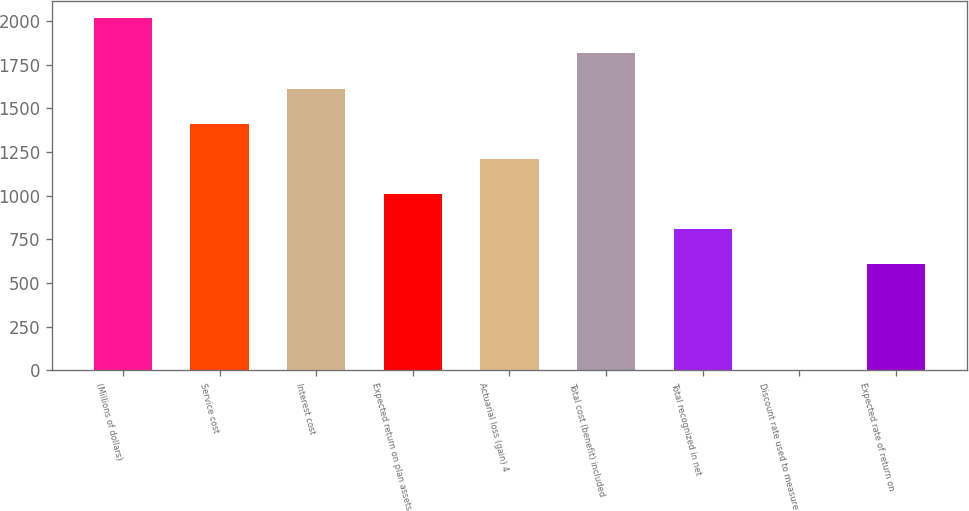Convert chart to OTSL. <chart><loc_0><loc_0><loc_500><loc_500><bar_chart><fcel>(Millions of dollars)<fcel>Service cost<fcel>Interest cost<fcel>Expected return on plan assets<fcel>Actuarial loss (gain) 4<fcel>Total cost (benefit) included<fcel>Total recognized in net<fcel>Discount rate used to measure<fcel>Expected rate of return on<nl><fcel>2016<fcel>1412.19<fcel>1613.46<fcel>1009.65<fcel>1210.92<fcel>1814.73<fcel>808.38<fcel>3.3<fcel>607.11<nl></chart> 